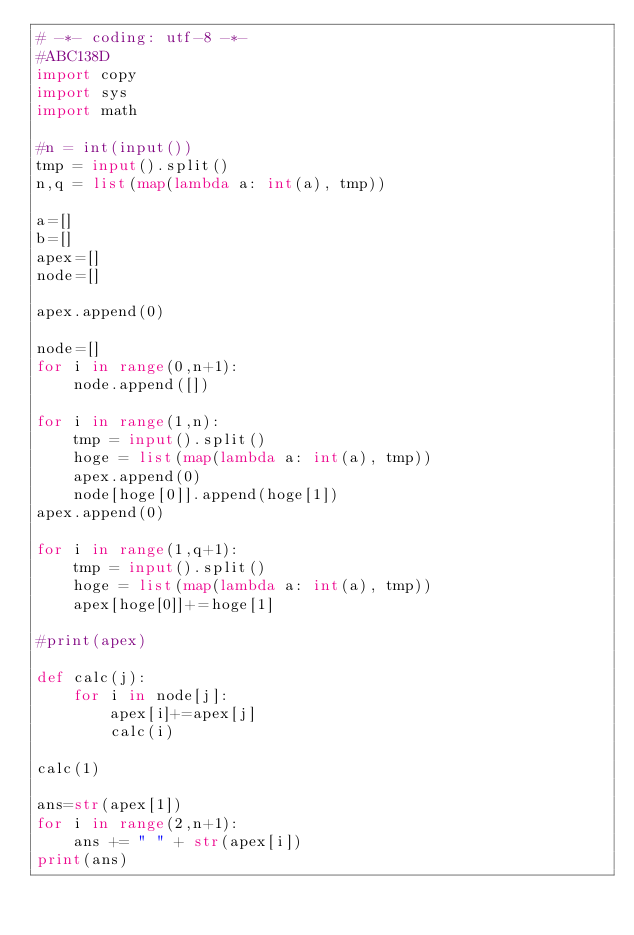Convert code to text. <code><loc_0><loc_0><loc_500><loc_500><_Python_># -*- coding: utf-8 -*-
#ABC138D
import copy
import sys
import math

#n = int(input())
tmp = input().split()
n,q = list(map(lambda a: int(a), tmp))

a=[]
b=[]
apex=[]
node=[]

apex.append(0)

node=[]
for i in range(0,n+1):
	node.append([])

for i in range(1,n):
	tmp = input().split()
	hoge = list(map(lambda a: int(a), tmp))
	apex.append(0)
	node[hoge[0]].append(hoge[1])
apex.append(0)

for i in range(1,q+1):
	tmp = input().split()
	hoge = list(map(lambda a: int(a), tmp))
	apex[hoge[0]]+=hoge[1]

#print(apex)

def calc(j):
	for i in node[j]:
		apex[i]+=apex[j]
		calc(i)

calc(1)

ans=str(apex[1])
for i in range(2,n+1):
	ans += " " + str(apex[i])
print(ans)</code> 